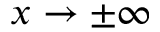Convert formula to latex. <formula><loc_0><loc_0><loc_500><loc_500>x \to \pm \infty</formula> 